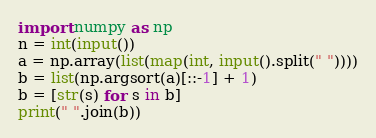<code> <loc_0><loc_0><loc_500><loc_500><_Python_>import numpy as np
n = int(input())
a = np.array(list(map(int, input().split(" "))))
b = list(np.argsort(a)[::-1] + 1)
b = [str(s) for s in b]
print(" ".join(b))</code> 